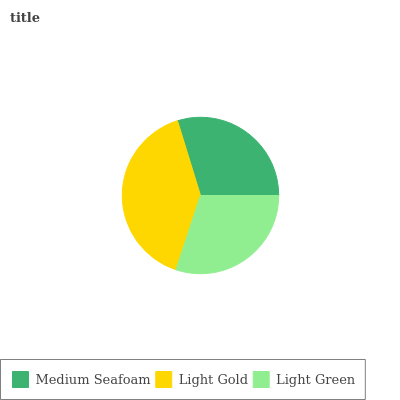Is Medium Seafoam the minimum?
Answer yes or no. Yes. Is Light Gold the maximum?
Answer yes or no. Yes. Is Light Green the minimum?
Answer yes or no. No. Is Light Green the maximum?
Answer yes or no. No. Is Light Gold greater than Light Green?
Answer yes or no. Yes. Is Light Green less than Light Gold?
Answer yes or no. Yes. Is Light Green greater than Light Gold?
Answer yes or no. No. Is Light Gold less than Light Green?
Answer yes or no. No. Is Light Green the high median?
Answer yes or no. Yes. Is Light Green the low median?
Answer yes or no. Yes. Is Medium Seafoam the high median?
Answer yes or no. No. Is Light Gold the low median?
Answer yes or no. No. 